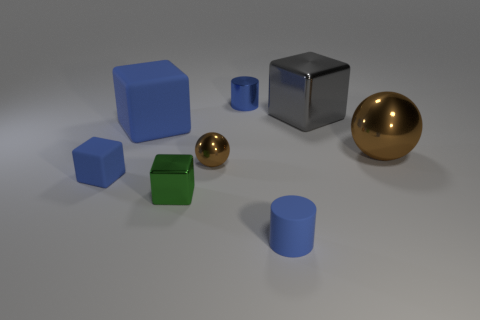Subtract all brown spheres. How many blue blocks are left? 2 Subtract all large blue blocks. How many blocks are left? 3 Subtract 2 blocks. How many blocks are left? 2 Subtract all green cubes. How many cubes are left? 3 Add 1 gray metal blocks. How many objects exist? 9 Subtract all cyan blocks. Subtract all yellow spheres. How many blocks are left? 4 Subtract all cylinders. How many objects are left? 6 Add 1 tiny green things. How many tiny green things exist? 2 Subtract 0 green cylinders. How many objects are left? 8 Subtract all metal spheres. Subtract all small brown matte things. How many objects are left? 6 